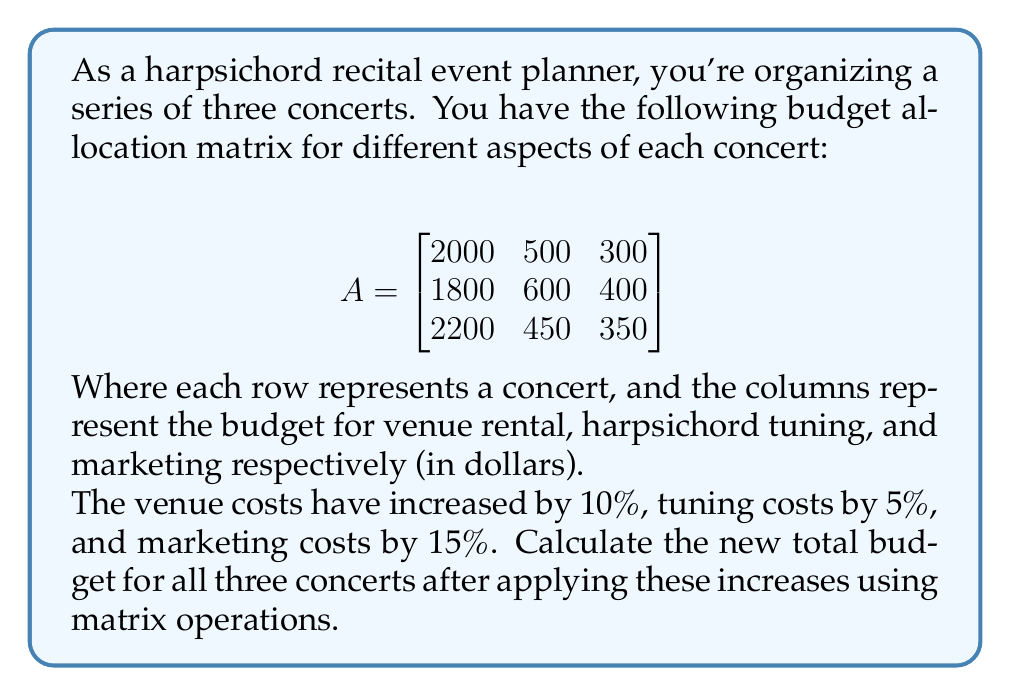Could you help me with this problem? Let's approach this step-by-step:

1) First, we need to create a matrix that represents the percentage increases:

   $$B = \begin{bmatrix}
   1.10 & 0 & 0 \\
   0 & 1.05 & 0 \\
   0 & 0 & 1.15
   \end{bmatrix}$$

2) To apply these increases, we need to multiply matrix A by matrix B:

   $$C = A \times B$$

3) Performing the matrix multiplication:

   $$C = \begin{bmatrix}
   2000 & 500 & 300 \\
   1800 & 600 & 400 \\
   2200 & 450 & 350
   \end{bmatrix} \times 
   \begin{bmatrix}
   1.10 & 0 & 0 \\
   0 & 1.05 & 0 \\
   0 & 0 & 1.15
   \end{bmatrix}$$

   $$C = \begin{bmatrix}
   2200 & 525 & 345 \\
   1980 & 630 & 460 \\
   2420 & 472.50 & 402.50
   \end{bmatrix}$$

4) Now, to find the total budget, we need to sum all elements of matrix C. We can do this by multiplying C by a column vector of ones:

   $$\text{Total} = C \times \begin{bmatrix} 1 \\ 1 \\ 1 \end{bmatrix}$$

5) Performing this multiplication:

   $$\text{Total} = \begin{bmatrix}
   2200 & 525 & 345 \\
   1980 & 630 & 460 \\
   2420 & 472.50 & 402.50
   \end{bmatrix} \times \begin{bmatrix} 1 \\ 1 \\ 1 \end{bmatrix}
   = \begin{bmatrix}
   3070 \\
   3070 \\
   3295
   \end{bmatrix}$$

6) The total budget is the sum of these values:

   $3070 + 3070 + 3295 = 9435$

Therefore, the new total budget for all three concerts after applying the increases is $9,435.
Answer: $9,435 